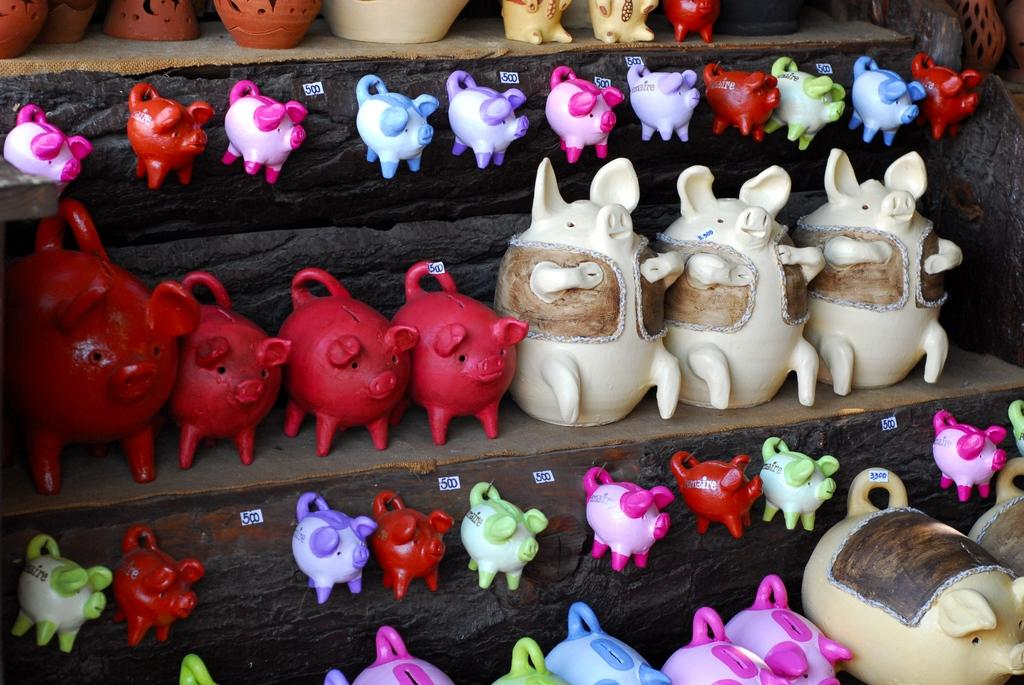What type of objects can be seen in the image? There are toys in the image. Where are the toys located? The toys are on a wooden object. Are there any additional details about the objects in the image? Yes, there are labels with text in the image. What type of rhythm can be heard coming from the stage in the image? There is no stage or rhythm present in the image; it features toys on a wooden object with labels. 